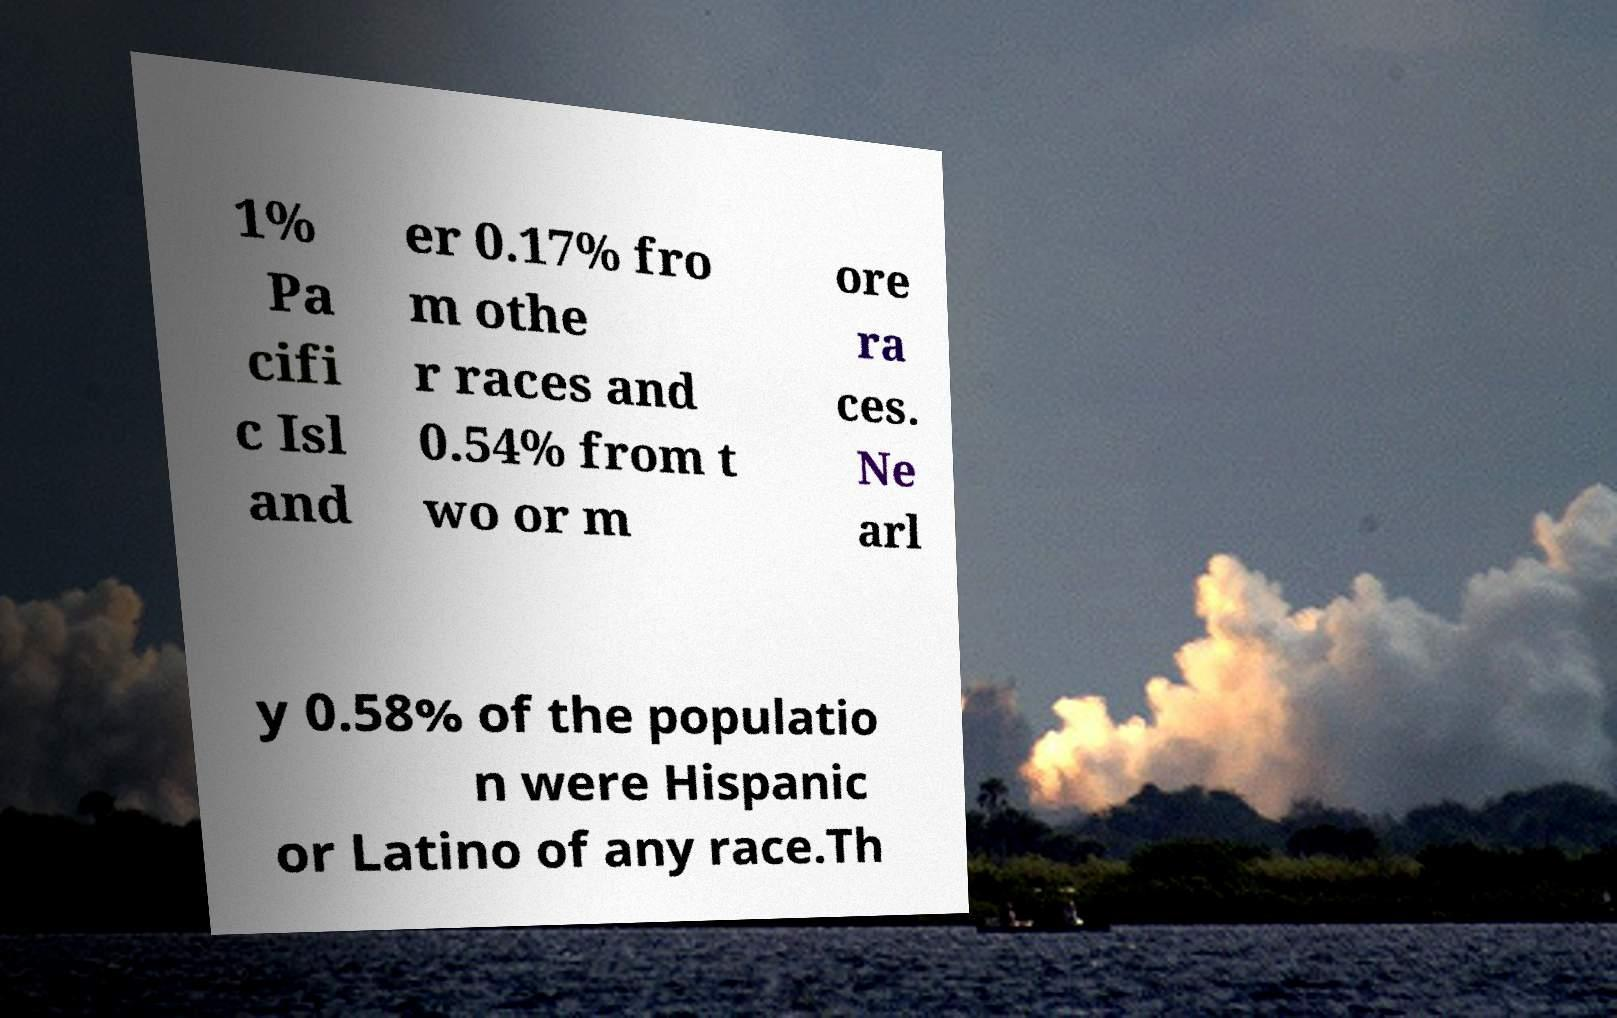Please read and relay the text visible in this image. What does it say? 1% Pa cifi c Isl and er 0.17% fro m othe r races and 0.54% from t wo or m ore ra ces. Ne arl y 0.58% of the populatio n were Hispanic or Latino of any race.Th 